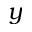<formula> <loc_0><loc_0><loc_500><loc_500>y</formula> 